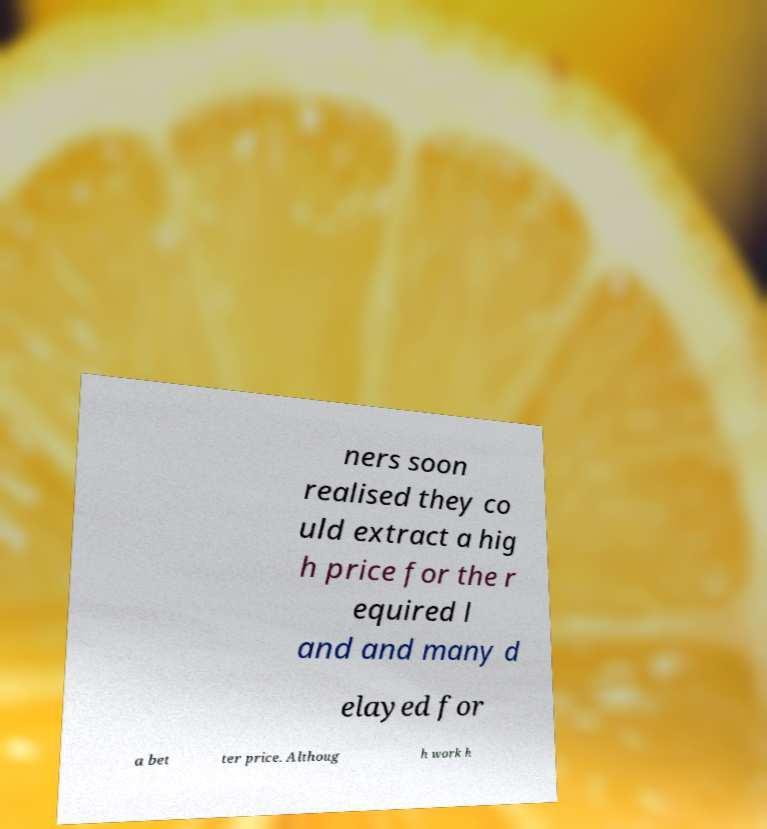Please identify and transcribe the text found in this image. ners soon realised they co uld extract a hig h price for the r equired l and and many d elayed for a bet ter price. Althoug h work h 